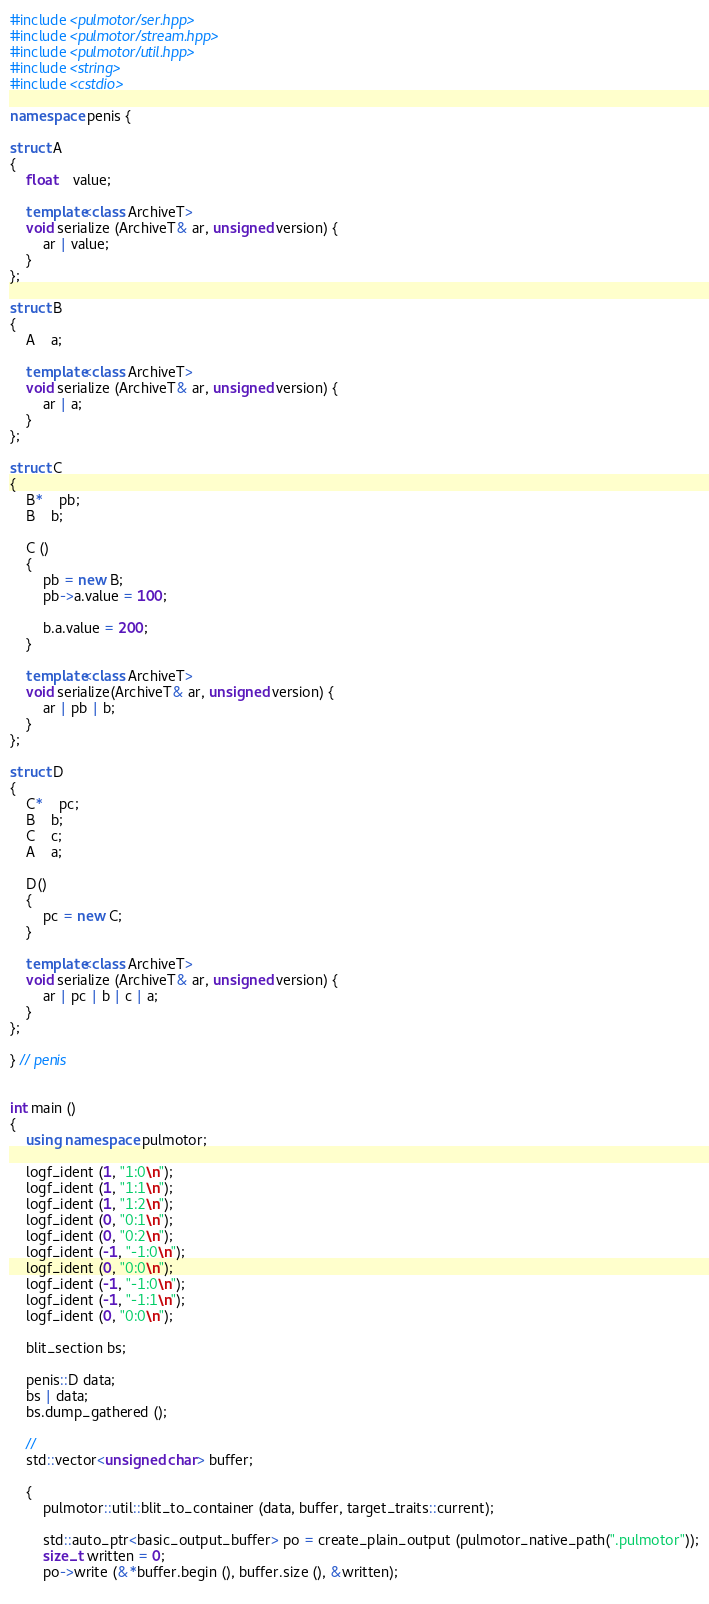<code> <loc_0><loc_0><loc_500><loc_500><_C++_>#include <pulmotor/ser.hpp>
#include <pulmotor/stream.hpp>
#include <pulmotor/util.hpp>
#include <string>
#include <cstdio>

namespace penis {

struct A
{
	float	value;
	
	template<class ArchiveT>
	void serialize (ArchiveT& ar, unsigned version) {
		ar | value;
	}
};

struct B
{
	A	a;

	template<class ArchiveT>
	void serialize (ArchiveT& ar, unsigned version) {
		ar | a;
	}
};

struct C
{
	B*	pb;
	B	b;

	C ()
	{
		pb = new B;
		pb->a.value = 100;

		b.a.value = 200;
	}

	template<class ArchiveT>
	void serialize(ArchiveT& ar, unsigned version) {
		ar | pb | b;
	}
};

struct D
{
	C*	pc;
	B	b;
	C	c;
	A	a;

	D()
	{
		pc = new C;
	}

	template<class ArchiveT>
	void serialize (ArchiveT& ar, unsigned version) {
		ar | pc | b | c | a;
	}
};

} // penis


int main ()
{
	using namespace pulmotor;

	logf_ident (1, "1:0\n");
	logf_ident (1, "1:1\n");
	logf_ident (1, "1:2\n");
	logf_ident (0, "0:1\n");
	logf_ident (0, "0:2\n");
	logf_ident (-1, "-1:0\n");
	logf_ident (0, "0:0\n");
	logf_ident (-1, "-1:0\n");
	logf_ident (-1, "-1:1\n");
	logf_ident (0, "0:0\n");
	
	blit_section bs;
	
	penis::D data;
	bs | data;
	bs.dump_gathered ();

	//
	std::vector<unsigned char> buffer;
	
	{
		pulmotor::util::blit_to_container (data, buffer, target_traits::current);

		std::auto_ptr<basic_output_buffer> po = create_plain_output (pulmotor_native_path(".pulmotor"));
		size_t written = 0;
		po->write (&*buffer.begin (), buffer.size (), &written);
		</code> 